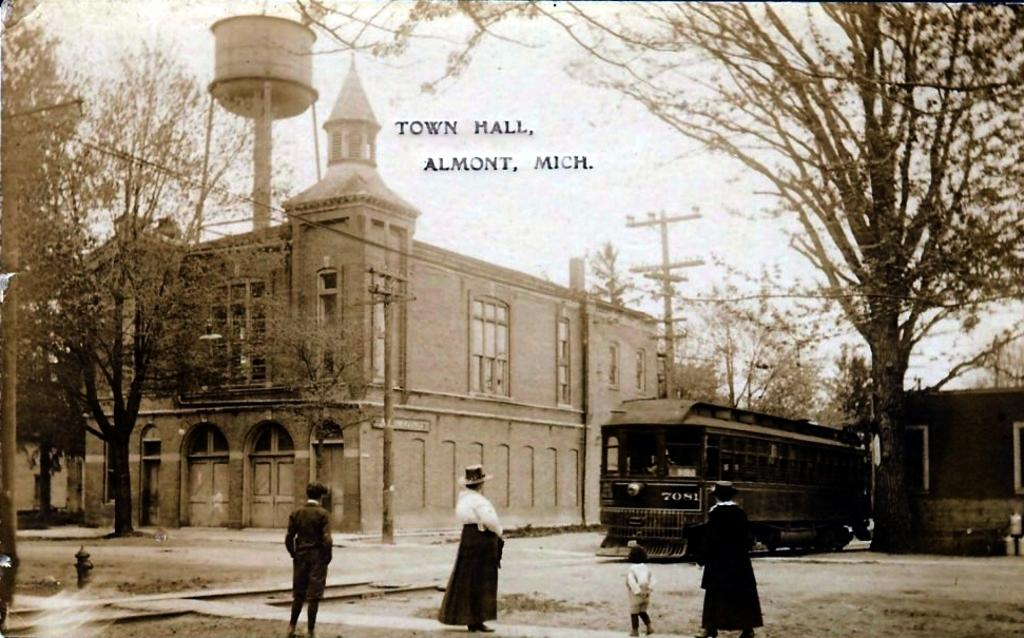What type of picture is the image? The image is an old picture. What can be seen on the ground in the image? There is a road in the image, and a bus is present on the road. Who or what is visible in the image? There are persons in the image. What type of natural elements can be seen in the image? Trees are visible in the image. What type of man-made structures can be seen in the image? Buildings are present in the image. What part of the natural environment is visible in the image? The sky is visible in the image. What else can be seen in the image besides the road, bus, persons, trees, buildings, and sky? Poles are present in the image. What type of wood is the son using to build a duck in the image? There is no son or duck present in the image, and therefore no wood or building activity can be observed. 